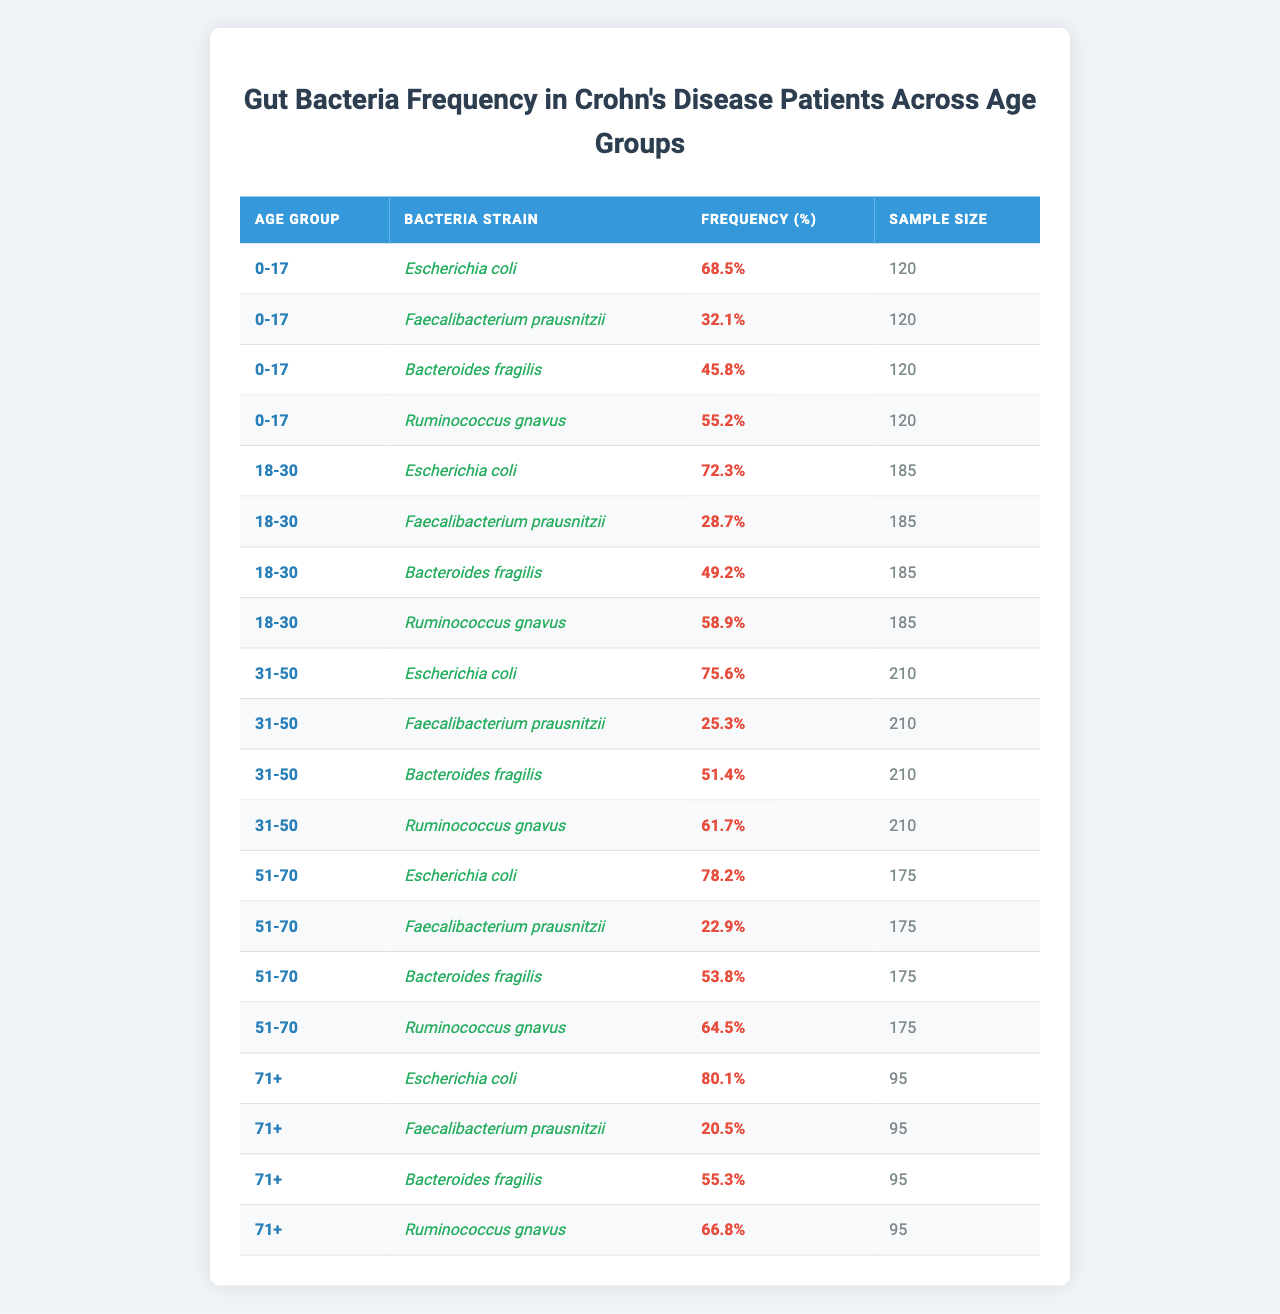What is the frequency of Escherichia coli in the 31-50 age group? From the table, when I look under the "31-50" age group for the "Escherichia coli" bacteria strain, it shows a frequency of 75.6%.
Answer: 75.6% Which age group shows the highest frequency of Faecalibacterium prausnitzii? In the table, the frequency of Faecalibacterium prausnitzii decreases as the age groups increase. The highest is found in the "0-17" age group with a frequency of 32.1%.
Answer: 0-17 How many total samples were taken for the 51-70 age group? The table shows that the sample size for the "51-70" age group is 175.
Answer: 175 What is the average frequency of Ruminococcus gnavus across all age groups? To find the average, I add the frequencies of Ruminococcus gnavus: (55.2 + 58.9 + 61.7 + 64.5 + 66.8) = 307.1. There are 5 age groups, so I divide 307.1 by 5, yielding an average of 61.42%.
Answer: 61.4% Is the frequency of Bacteroides fragilis higher in the 18-30 age group than in the 0-17 age group? Checking the table, Bacteroides fragilis shows 49.2% in the 18-30 age group and 45.8% in the 0-17 age group. Since 49.2% is greater than 45.8%, the statement is true.
Answer: Yes What is the difference in frequency of Escherichia coli between the 51-70 and 71+ age groups? The frequency of Escherichia coli in the 51-70 age group is 78.2%, and in the 71+ age group, it is 80.1%. The difference is 80.1 - 78.2 = 1.9%.
Answer: 1.9% In which age group does Bacteroides fragilis have the lowest frequency? Looking at the table, I see that Bacteroides fragilis has the lowest frequency in the "18-30" age group with 49.2%.
Answer: 18-30 Is there a trend in the frequency of Faecalibacterium prausnitzii as age increases? Analyzing the table, Faecalibacterium prausnitzii's frequency decreases as the age groups increase: 32.1% for 0-17, down to 20.5% for 71+. This confirms a downward trend.
Answer: Yes What percentage of the sample size does the frequency of Ruminococcus gnavus represent in the 0-17 age group? The frequency of Ruminococcus gnavus in the 0-17 age group is 55.2%, and the sample size is 120. To find the number of samples it represents: 120 * (55.2/100) = 66.24, approximately 66 samples.
Answer: 66 samples Which bacteria strain has the highest frequency in the 0-17 age group? Reviewing the table, Escherichia coli has the highest frequency at 68.5% in the 0-17 age group.
Answer: Escherichia coli 